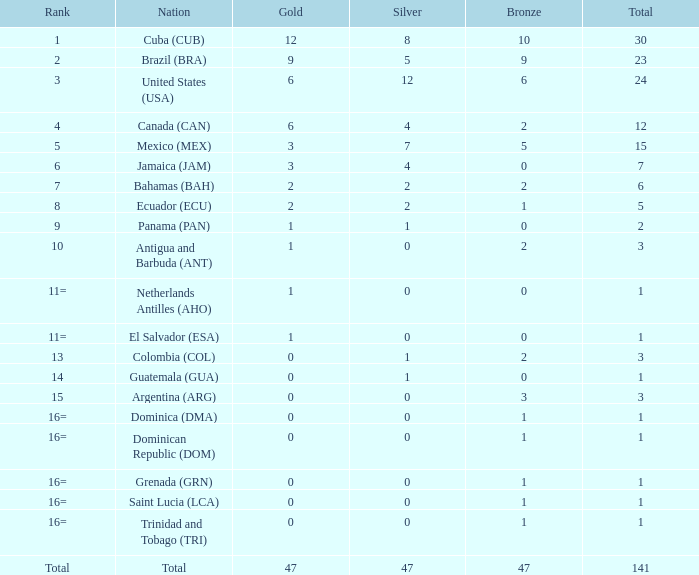What is the complete gold quantity with a total under 1? None. 